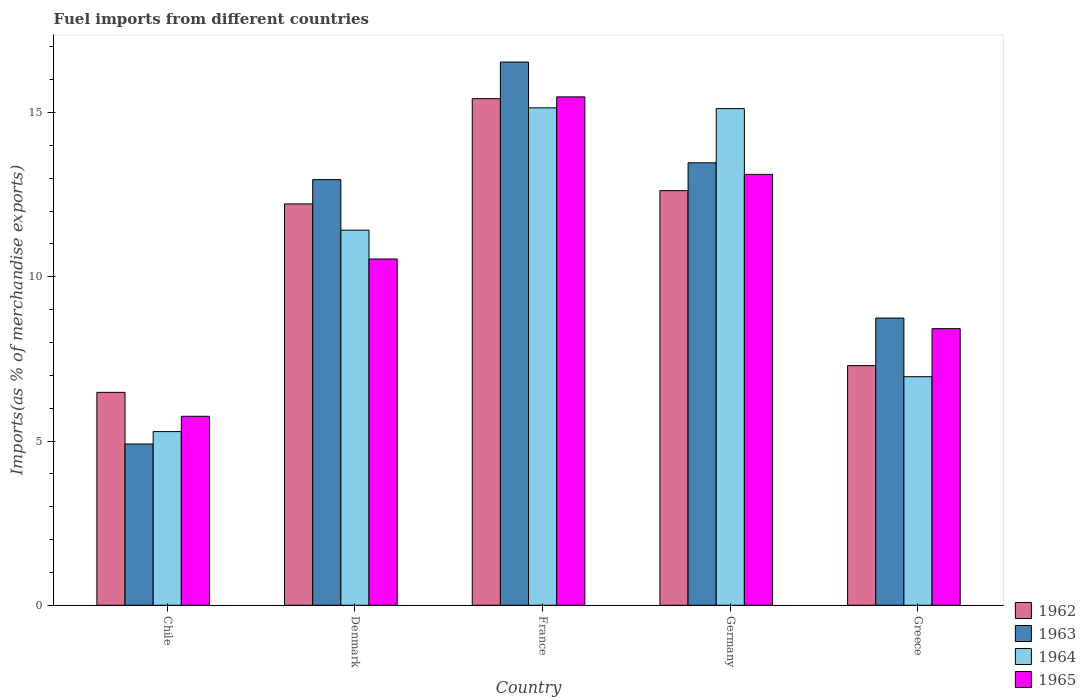How many different coloured bars are there?
Provide a short and direct response. 4. Are the number of bars per tick equal to the number of legend labels?
Your answer should be compact. Yes. Are the number of bars on each tick of the X-axis equal?
Offer a terse response. Yes. How many bars are there on the 1st tick from the left?
Give a very brief answer. 4. How many bars are there on the 5th tick from the right?
Your answer should be compact. 4. In how many cases, is the number of bars for a given country not equal to the number of legend labels?
Your response must be concise. 0. What is the percentage of imports to different countries in 1965 in France?
Provide a short and direct response. 15.48. Across all countries, what is the maximum percentage of imports to different countries in 1964?
Provide a succinct answer. 15.14. Across all countries, what is the minimum percentage of imports to different countries in 1963?
Offer a terse response. 4.91. In which country was the percentage of imports to different countries in 1965 maximum?
Your response must be concise. France. In which country was the percentage of imports to different countries in 1963 minimum?
Your answer should be compact. Chile. What is the total percentage of imports to different countries in 1964 in the graph?
Provide a short and direct response. 53.93. What is the difference between the percentage of imports to different countries in 1962 in Chile and that in Greece?
Your response must be concise. -0.81. What is the difference between the percentage of imports to different countries in 1964 in France and the percentage of imports to different countries in 1965 in Greece?
Your response must be concise. 6.72. What is the average percentage of imports to different countries in 1963 per country?
Offer a very short reply. 11.32. What is the difference between the percentage of imports to different countries of/in 1963 and percentage of imports to different countries of/in 1965 in Germany?
Provide a succinct answer. 0.35. In how many countries, is the percentage of imports to different countries in 1965 greater than 1 %?
Keep it short and to the point. 5. What is the ratio of the percentage of imports to different countries in 1964 in Denmark to that in Greece?
Provide a short and direct response. 1.64. Is the percentage of imports to different countries in 1965 in Denmark less than that in Greece?
Make the answer very short. No. Is the difference between the percentage of imports to different countries in 1963 in Chile and France greater than the difference between the percentage of imports to different countries in 1965 in Chile and France?
Provide a succinct answer. No. What is the difference between the highest and the second highest percentage of imports to different countries in 1965?
Your answer should be very brief. -2.58. What is the difference between the highest and the lowest percentage of imports to different countries in 1965?
Your answer should be compact. 9.72. In how many countries, is the percentage of imports to different countries in 1964 greater than the average percentage of imports to different countries in 1964 taken over all countries?
Your answer should be very brief. 3. Is the sum of the percentage of imports to different countries in 1963 in Chile and France greater than the maximum percentage of imports to different countries in 1965 across all countries?
Provide a short and direct response. Yes. Is it the case that in every country, the sum of the percentage of imports to different countries in 1963 and percentage of imports to different countries in 1964 is greater than the sum of percentage of imports to different countries in 1965 and percentage of imports to different countries in 1962?
Provide a short and direct response. No. What does the 2nd bar from the left in Denmark represents?
Keep it short and to the point. 1963. What does the 2nd bar from the right in Germany represents?
Make the answer very short. 1964. Is it the case that in every country, the sum of the percentage of imports to different countries in 1964 and percentage of imports to different countries in 1962 is greater than the percentage of imports to different countries in 1965?
Your answer should be very brief. Yes. How many bars are there?
Your response must be concise. 20. Are the values on the major ticks of Y-axis written in scientific E-notation?
Give a very brief answer. No. Does the graph contain grids?
Your response must be concise. No. How are the legend labels stacked?
Keep it short and to the point. Vertical. What is the title of the graph?
Make the answer very short. Fuel imports from different countries. What is the label or title of the Y-axis?
Offer a very short reply. Imports(as % of merchandise exports). What is the Imports(as % of merchandise exports) of 1962 in Chile?
Keep it short and to the point. 6.48. What is the Imports(as % of merchandise exports) of 1963 in Chile?
Provide a short and direct response. 4.91. What is the Imports(as % of merchandise exports) of 1964 in Chile?
Your response must be concise. 5.29. What is the Imports(as % of merchandise exports) of 1965 in Chile?
Give a very brief answer. 5.75. What is the Imports(as % of merchandise exports) of 1962 in Denmark?
Your answer should be compact. 12.22. What is the Imports(as % of merchandise exports) of 1963 in Denmark?
Your answer should be compact. 12.96. What is the Imports(as % of merchandise exports) in 1964 in Denmark?
Give a very brief answer. 11.42. What is the Imports(as % of merchandise exports) of 1965 in Denmark?
Your answer should be very brief. 10.54. What is the Imports(as % of merchandise exports) of 1962 in France?
Give a very brief answer. 15.42. What is the Imports(as % of merchandise exports) in 1963 in France?
Keep it short and to the point. 16.54. What is the Imports(as % of merchandise exports) in 1964 in France?
Your response must be concise. 15.14. What is the Imports(as % of merchandise exports) in 1965 in France?
Keep it short and to the point. 15.48. What is the Imports(as % of merchandise exports) in 1962 in Germany?
Offer a very short reply. 12.62. What is the Imports(as % of merchandise exports) of 1963 in Germany?
Ensure brevity in your answer.  13.47. What is the Imports(as % of merchandise exports) of 1964 in Germany?
Provide a short and direct response. 15.12. What is the Imports(as % of merchandise exports) of 1965 in Germany?
Your answer should be very brief. 13.12. What is the Imports(as % of merchandise exports) in 1962 in Greece?
Make the answer very short. 7.3. What is the Imports(as % of merchandise exports) in 1963 in Greece?
Your answer should be very brief. 8.74. What is the Imports(as % of merchandise exports) in 1964 in Greece?
Provide a succinct answer. 6.96. What is the Imports(as % of merchandise exports) of 1965 in Greece?
Make the answer very short. 8.42. Across all countries, what is the maximum Imports(as % of merchandise exports) in 1962?
Make the answer very short. 15.42. Across all countries, what is the maximum Imports(as % of merchandise exports) in 1963?
Offer a terse response. 16.54. Across all countries, what is the maximum Imports(as % of merchandise exports) of 1964?
Give a very brief answer. 15.14. Across all countries, what is the maximum Imports(as % of merchandise exports) in 1965?
Your answer should be compact. 15.48. Across all countries, what is the minimum Imports(as % of merchandise exports) of 1962?
Offer a terse response. 6.48. Across all countries, what is the minimum Imports(as % of merchandise exports) of 1963?
Your response must be concise. 4.91. Across all countries, what is the minimum Imports(as % of merchandise exports) in 1964?
Give a very brief answer. 5.29. Across all countries, what is the minimum Imports(as % of merchandise exports) of 1965?
Give a very brief answer. 5.75. What is the total Imports(as % of merchandise exports) of 1962 in the graph?
Your answer should be very brief. 54.04. What is the total Imports(as % of merchandise exports) of 1963 in the graph?
Provide a succinct answer. 56.62. What is the total Imports(as % of merchandise exports) of 1964 in the graph?
Give a very brief answer. 53.93. What is the total Imports(as % of merchandise exports) of 1965 in the graph?
Offer a terse response. 53.31. What is the difference between the Imports(as % of merchandise exports) in 1962 in Chile and that in Denmark?
Offer a terse response. -5.74. What is the difference between the Imports(as % of merchandise exports) of 1963 in Chile and that in Denmark?
Your answer should be very brief. -8.05. What is the difference between the Imports(as % of merchandise exports) in 1964 in Chile and that in Denmark?
Your answer should be very brief. -6.13. What is the difference between the Imports(as % of merchandise exports) of 1965 in Chile and that in Denmark?
Give a very brief answer. -4.79. What is the difference between the Imports(as % of merchandise exports) of 1962 in Chile and that in France?
Provide a succinct answer. -8.94. What is the difference between the Imports(as % of merchandise exports) in 1963 in Chile and that in France?
Ensure brevity in your answer.  -11.63. What is the difference between the Imports(as % of merchandise exports) of 1964 in Chile and that in France?
Your answer should be very brief. -9.86. What is the difference between the Imports(as % of merchandise exports) of 1965 in Chile and that in France?
Your answer should be very brief. -9.72. What is the difference between the Imports(as % of merchandise exports) in 1962 in Chile and that in Germany?
Provide a succinct answer. -6.14. What is the difference between the Imports(as % of merchandise exports) of 1963 in Chile and that in Germany?
Provide a short and direct response. -8.56. What is the difference between the Imports(as % of merchandise exports) of 1964 in Chile and that in Germany?
Keep it short and to the point. -9.83. What is the difference between the Imports(as % of merchandise exports) of 1965 in Chile and that in Germany?
Keep it short and to the point. -7.36. What is the difference between the Imports(as % of merchandise exports) of 1962 in Chile and that in Greece?
Ensure brevity in your answer.  -0.81. What is the difference between the Imports(as % of merchandise exports) of 1963 in Chile and that in Greece?
Offer a terse response. -3.83. What is the difference between the Imports(as % of merchandise exports) in 1964 in Chile and that in Greece?
Give a very brief answer. -1.67. What is the difference between the Imports(as % of merchandise exports) of 1965 in Chile and that in Greece?
Keep it short and to the point. -2.67. What is the difference between the Imports(as % of merchandise exports) of 1962 in Denmark and that in France?
Your response must be concise. -3.2. What is the difference between the Imports(as % of merchandise exports) of 1963 in Denmark and that in France?
Your answer should be very brief. -3.58. What is the difference between the Imports(as % of merchandise exports) in 1964 in Denmark and that in France?
Provide a succinct answer. -3.72. What is the difference between the Imports(as % of merchandise exports) of 1965 in Denmark and that in France?
Provide a succinct answer. -4.94. What is the difference between the Imports(as % of merchandise exports) in 1962 in Denmark and that in Germany?
Provide a succinct answer. -0.4. What is the difference between the Imports(as % of merchandise exports) in 1963 in Denmark and that in Germany?
Your response must be concise. -0.51. What is the difference between the Imports(as % of merchandise exports) of 1964 in Denmark and that in Germany?
Make the answer very short. -3.7. What is the difference between the Imports(as % of merchandise exports) in 1965 in Denmark and that in Germany?
Offer a terse response. -2.58. What is the difference between the Imports(as % of merchandise exports) in 1962 in Denmark and that in Greece?
Provide a short and direct response. 4.92. What is the difference between the Imports(as % of merchandise exports) in 1963 in Denmark and that in Greece?
Offer a terse response. 4.21. What is the difference between the Imports(as % of merchandise exports) in 1964 in Denmark and that in Greece?
Your response must be concise. 4.46. What is the difference between the Imports(as % of merchandise exports) in 1965 in Denmark and that in Greece?
Give a very brief answer. 2.12. What is the difference between the Imports(as % of merchandise exports) in 1962 in France and that in Germany?
Your response must be concise. 2.8. What is the difference between the Imports(as % of merchandise exports) of 1963 in France and that in Germany?
Give a very brief answer. 3.07. What is the difference between the Imports(as % of merchandise exports) in 1964 in France and that in Germany?
Give a very brief answer. 0.02. What is the difference between the Imports(as % of merchandise exports) in 1965 in France and that in Germany?
Offer a very short reply. 2.36. What is the difference between the Imports(as % of merchandise exports) of 1962 in France and that in Greece?
Keep it short and to the point. 8.13. What is the difference between the Imports(as % of merchandise exports) in 1963 in France and that in Greece?
Your answer should be compact. 7.79. What is the difference between the Imports(as % of merchandise exports) of 1964 in France and that in Greece?
Your response must be concise. 8.19. What is the difference between the Imports(as % of merchandise exports) in 1965 in France and that in Greece?
Give a very brief answer. 7.06. What is the difference between the Imports(as % of merchandise exports) in 1962 in Germany and that in Greece?
Offer a very short reply. 5.33. What is the difference between the Imports(as % of merchandise exports) in 1963 in Germany and that in Greece?
Give a very brief answer. 4.73. What is the difference between the Imports(as % of merchandise exports) of 1964 in Germany and that in Greece?
Keep it short and to the point. 8.16. What is the difference between the Imports(as % of merchandise exports) in 1965 in Germany and that in Greece?
Provide a short and direct response. 4.7. What is the difference between the Imports(as % of merchandise exports) of 1962 in Chile and the Imports(as % of merchandise exports) of 1963 in Denmark?
Offer a very short reply. -6.48. What is the difference between the Imports(as % of merchandise exports) in 1962 in Chile and the Imports(as % of merchandise exports) in 1964 in Denmark?
Your answer should be very brief. -4.94. What is the difference between the Imports(as % of merchandise exports) in 1962 in Chile and the Imports(as % of merchandise exports) in 1965 in Denmark?
Give a very brief answer. -4.06. What is the difference between the Imports(as % of merchandise exports) in 1963 in Chile and the Imports(as % of merchandise exports) in 1964 in Denmark?
Make the answer very short. -6.51. What is the difference between the Imports(as % of merchandise exports) in 1963 in Chile and the Imports(as % of merchandise exports) in 1965 in Denmark?
Your answer should be very brief. -5.63. What is the difference between the Imports(as % of merchandise exports) in 1964 in Chile and the Imports(as % of merchandise exports) in 1965 in Denmark?
Make the answer very short. -5.25. What is the difference between the Imports(as % of merchandise exports) in 1962 in Chile and the Imports(as % of merchandise exports) in 1963 in France?
Make the answer very short. -10.06. What is the difference between the Imports(as % of merchandise exports) of 1962 in Chile and the Imports(as % of merchandise exports) of 1964 in France?
Provide a short and direct response. -8.66. What is the difference between the Imports(as % of merchandise exports) in 1962 in Chile and the Imports(as % of merchandise exports) in 1965 in France?
Your answer should be compact. -9. What is the difference between the Imports(as % of merchandise exports) in 1963 in Chile and the Imports(as % of merchandise exports) in 1964 in France?
Offer a terse response. -10.23. What is the difference between the Imports(as % of merchandise exports) in 1963 in Chile and the Imports(as % of merchandise exports) in 1965 in France?
Offer a terse response. -10.57. What is the difference between the Imports(as % of merchandise exports) of 1964 in Chile and the Imports(as % of merchandise exports) of 1965 in France?
Give a very brief answer. -10.19. What is the difference between the Imports(as % of merchandise exports) of 1962 in Chile and the Imports(as % of merchandise exports) of 1963 in Germany?
Your answer should be very brief. -6.99. What is the difference between the Imports(as % of merchandise exports) of 1962 in Chile and the Imports(as % of merchandise exports) of 1964 in Germany?
Ensure brevity in your answer.  -8.64. What is the difference between the Imports(as % of merchandise exports) of 1962 in Chile and the Imports(as % of merchandise exports) of 1965 in Germany?
Offer a very short reply. -6.64. What is the difference between the Imports(as % of merchandise exports) of 1963 in Chile and the Imports(as % of merchandise exports) of 1964 in Germany?
Provide a succinct answer. -10.21. What is the difference between the Imports(as % of merchandise exports) in 1963 in Chile and the Imports(as % of merchandise exports) in 1965 in Germany?
Make the answer very short. -8.21. What is the difference between the Imports(as % of merchandise exports) in 1964 in Chile and the Imports(as % of merchandise exports) in 1965 in Germany?
Offer a terse response. -7.83. What is the difference between the Imports(as % of merchandise exports) in 1962 in Chile and the Imports(as % of merchandise exports) in 1963 in Greece?
Your answer should be very brief. -2.26. What is the difference between the Imports(as % of merchandise exports) of 1962 in Chile and the Imports(as % of merchandise exports) of 1964 in Greece?
Your answer should be very brief. -0.48. What is the difference between the Imports(as % of merchandise exports) of 1962 in Chile and the Imports(as % of merchandise exports) of 1965 in Greece?
Your response must be concise. -1.94. What is the difference between the Imports(as % of merchandise exports) in 1963 in Chile and the Imports(as % of merchandise exports) in 1964 in Greece?
Offer a terse response. -2.05. What is the difference between the Imports(as % of merchandise exports) in 1963 in Chile and the Imports(as % of merchandise exports) in 1965 in Greece?
Provide a succinct answer. -3.51. What is the difference between the Imports(as % of merchandise exports) in 1964 in Chile and the Imports(as % of merchandise exports) in 1965 in Greece?
Your answer should be compact. -3.13. What is the difference between the Imports(as % of merchandise exports) of 1962 in Denmark and the Imports(as % of merchandise exports) of 1963 in France?
Provide a short and direct response. -4.32. What is the difference between the Imports(as % of merchandise exports) of 1962 in Denmark and the Imports(as % of merchandise exports) of 1964 in France?
Give a very brief answer. -2.92. What is the difference between the Imports(as % of merchandise exports) in 1962 in Denmark and the Imports(as % of merchandise exports) in 1965 in France?
Ensure brevity in your answer.  -3.26. What is the difference between the Imports(as % of merchandise exports) of 1963 in Denmark and the Imports(as % of merchandise exports) of 1964 in France?
Your response must be concise. -2.19. What is the difference between the Imports(as % of merchandise exports) in 1963 in Denmark and the Imports(as % of merchandise exports) in 1965 in France?
Keep it short and to the point. -2.52. What is the difference between the Imports(as % of merchandise exports) in 1964 in Denmark and the Imports(as % of merchandise exports) in 1965 in France?
Your response must be concise. -4.06. What is the difference between the Imports(as % of merchandise exports) of 1962 in Denmark and the Imports(as % of merchandise exports) of 1963 in Germany?
Your response must be concise. -1.25. What is the difference between the Imports(as % of merchandise exports) in 1962 in Denmark and the Imports(as % of merchandise exports) in 1964 in Germany?
Offer a terse response. -2.9. What is the difference between the Imports(as % of merchandise exports) in 1962 in Denmark and the Imports(as % of merchandise exports) in 1965 in Germany?
Your response must be concise. -0.9. What is the difference between the Imports(as % of merchandise exports) of 1963 in Denmark and the Imports(as % of merchandise exports) of 1964 in Germany?
Give a very brief answer. -2.16. What is the difference between the Imports(as % of merchandise exports) of 1963 in Denmark and the Imports(as % of merchandise exports) of 1965 in Germany?
Your answer should be compact. -0.16. What is the difference between the Imports(as % of merchandise exports) in 1964 in Denmark and the Imports(as % of merchandise exports) in 1965 in Germany?
Your answer should be compact. -1.7. What is the difference between the Imports(as % of merchandise exports) in 1962 in Denmark and the Imports(as % of merchandise exports) in 1963 in Greece?
Your response must be concise. 3.48. What is the difference between the Imports(as % of merchandise exports) in 1962 in Denmark and the Imports(as % of merchandise exports) in 1964 in Greece?
Provide a succinct answer. 5.26. What is the difference between the Imports(as % of merchandise exports) of 1962 in Denmark and the Imports(as % of merchandise exports) of 1965 in Greece?
Your answer should be compact. 3.8. What is the difference between the Imports(as % of merchandise exports) of 1963 in Denmark and the Imports(as % of merchandise exports) of 1964 in Greece?
Your response must be concise. 6. What is the difference between the Imports(as % of merchandise exports) of 1963 in Denmark and the Imports(as % of merchandise exports) of 1965 in Greece?
Offer a terse response. 4.54. What is the difference between the Imports(as % of merchandise exports) of 1964 in Denmark and the Imports(as % of merchandise exports) of 1965 in Greece?
Offer a very short reply. 3. What is the difference between the Imports(as % of merchandise exports) in 1962 in France and the Imports(as % of merchandise exports) in 1963 in Germany?
Keep it short and to the point. 1.95. What is the difference between the Imports(as % of merchandise exports) in 1962 in France and the Imports(as % of merchandise exports) in 1964 in Germany?
Make the answer very short. 0.3. What is the difference between the Imports(as % of merchandise exports) in 1962 in France and the Imports(as % of merchandise exports) in 1965 in Germany?
Your answer should be very brief. 2.31. What is the difference between the Imports(as % of merchandise exports) of 1963 in France and the Imports(as % of merchandise exports) of 1964 in Germany?
Provide a short and direct response. 1.42. What is the difference between the Imports(as % of merchandise exports) of 1963 in France and the Imports(as % of merchandise exports) of 1965 in Germany?
Your answer should be very brief. 3.42. What is the difference between the Imports(as % of merchandise exports) in 1964 in France and the Imports(as % of merchandise exports) in 1965 in Germany?
Give a very brief answer. 2.03. What is the difference between the Imports(as % of merchandise exports) in 1962 in France and the Imports(as % of merchandise exports) in 1963 in Greece?
Offer a terse response. 6.68. What is the difference between the Imports(as % of merchandise exports) of 1962 in France and the Imports(as % of merchandise exports) of 1964 in Greece?
Offer a terse response. 8.46. What is the difference between the Imports(as % of merchandise exports) of 1962 in France and the Imports(as % of merchandise exports) of 1965 in Greece?
Keep it short and to the point. 7. What is the difference between the Imports(as % of merchandise exports) of 1963 in France and the Imports(as % of merchandise exports) of 1964 in Greece?
Provide a succinct answer. 9.58. What is the difference between the Imports(as % of merchandise exports) in 1963 in France and the Imports(as % of merchandise exports) in 1965 in Greece?
Offer a very short reply. 8.12. What is the difference between the Imports(as % of merchandise exports) in 1964 in France and the Imports(as % of merchandise exports) in 1965 in Greece?
Provide a short and direct response. 6.72. What is the difference between the Imports(as % of merchandise exports) in 1962 in Germany and the Imports(as % of merchandise exports) in 1963 in Greece?
Make the answer very short. 3.88. What is the difference between the Imports(as % of merchandise exports) of 1962 in Germany and the Imports(as % of merchandise exports) of 1964 in Greece?
Keep it short and to the point. 5.66. What is the difference between the Imports(as % of merchandise exports) in 1962 in Germany and the Imports(as % of merchandise exports) in 1965 in Greece?
Provide a short and direct response. 4.2. What is the difference between the Imports(as % of merchandise exports) of 1963 in Germany and the Imports(as % of merchandise exports) of 1964 in Greece?
Your answer should be very brief. 6.51. What is the difference between the Imports(as % of merchandise exports) in 1963 in Germany and the Imports(as % of merchandise exports) in 1965 in Greece?
Provide a succinct answer. 5.05. What is the difference between the Imports(as % of merchandise exports) in 1964 in Germany and the Imports(as % of merchandise exports) in 1965 in Greece?
Make the answer very short. 6.7. What is the average Imports(as % of merchandise exports) of 1962 per country?
Keep it short and to the point. 10.81. What is the average Imports(as % of merchandise exports) of 1963 per country?
Your response must be concise. 11.32. What is the average Imports(as % of merchandise exports) of 1964 per country?
Provide a succinct answer. 10.79. What is the average Imports(as % of merchandise exports) of 1965 per country?
Your answer should be very brief. 10.66. What is the difference between the Imports(as % of merchandise exports) in 1962 and Imports(as % of merchandise exports) in 1963 in Chile?
Provide a succinct answer. 1.57. What is the difference between the Imports(as % of merchandise exports) of 1962 and Imports(as % of merchandise exports) of 1964 in Chile?
Ensure brevity in your answer.  1.19. What is the difference between the Imports(as % of merchandise exports) of 1962 and Imports(as % of merchandise exports) of 1965 in Chile?
Keep it short and to the point. 0.73. What is the difference between the Imports(as % of merchandise exports) of 1963 and Imports(as % of merchandise exports) of 1964 in Chile?
Keep it short and to the point. -0.38. What is the difference between the Imports(as % of merchandise exports) of 1963 and Imports(as % of merchandise exports) of 1965 in Chile?
Offer a terse response. -0.84. What is the difference between the Imports(as % of merchandise exports) of 1964 and Imports(as % of merchandise exports) of 1965 in Chile?
Offer a terse response. -0.47. What is the difference between the Imports(as % of merchandise exports) in 1962 and Imports(as % of merchandise exports) in 1963 in Denmark?
Ensure brevity in your answer.  -0.74. What is the difference between the Imports(as % of merchandise exports) of 1962 and Imports(as % of merchandise exports) of 1964 in Denmark?
Ensure brevity in your answer.  0.8. What is the difference between the Imports(as % of merchandise exports) of 1962 and Imports(as % of merchandise exports) of 1965 in Denmark?
Give a very brief answer. 1.68. What is the difference between the Imports(as % of merchandise exports) in 1963 and Imports(as % of merchandise exports) in 1964 in Denmark?
Offer a very short reply. 1.54. What is the difference between the Imports(as % of merchandise exports) of 1963 and Imports(as % of merchandise exports) of 1965 in Denmark?
Offer a terse response. 2.42. What is the difference between the Imports(as % of merchandise exports) of 1964 and Imports(as % of merchandise exports) of 1965 in Denmark?
Keep it short and to the point. 0.88. What is the difference between the Imports(as % of merchandise exports) of 1962 and Imports(as % of merchandise exports) of 1963 in France?
Make the answer very short. -1.12. What is the difference between the Imports(as % of merchandise exports) of 1962 and Imports(as % of merchandise exports) of 1964 in France?
Make the answer very short. 0.28. What is the difference between the Imports(as % of merchandise exports) in 1962 and Imports(as % of merchandise exports) in 1965 in France?
Offer a terse response. -0.05. What is the difference between the Imports(as % of merchandise exports) of 1963 and Imports(as % of merchandise exports) of 1964 in France?
Your answer should be very brief. 1.39. What is the difference between the Imports(as % of merchandise exports) in 1963 and Imports(as % of merchandise exports) in 1965 in France?
Provide a short and direct response. 1.06. What is the difference between the Imports(as % of merchandise exports) of 1964 and Imports(as % of merchandise exports) of 1965 in France?
Give a very brief answer. -0.33. What is the difference between the Imports(as % of merchandise exports) in 1962 and Imports(as % of merchandise exports) in 1963 in Germany?
Offer a terse response. -0.85. What is the difference between the Imports(as % of merchandise exports) of 1962 and Imports(as % of merchandise exports) of 1964 in Germany?
Your response must be concise. -2.5. What is the difference between the Imports(as % of merchandise exports) of 1962 and Imports(as % of merchandise exports) of 1965 in Germany?
Your response must be concise. -0.49. What is the difference between the Imports(as % of merchandise exports) of 1963 and Imports(as % of merchandise exports) of 1964 in Germany?
Your answer should be compact. -1.65. What is the difference between the Imports(as % of merchandise exports) of 1963 and Imports(as % of merchandise exports) of 1965 in Germany?
Offer a very short reply. 0.35. What is the difference between the Imports(as % of merchandise exports) of 1964 and Imports(as % of merchandise exports) of 1965 in Germany?
Offer a very short reply. 2. What is the difference between the Imports(as % of merchandise exports) of 1962 and Imports(as % of merchandise exports) of 1963 in Greece?
Your answer should be compact. -1.45. What is the difference between the Imports(as % of merchandise exports) in 1962 and Imports(as % of merchandise exports) in 1964 in Greece?
Your answer should be very brief. 0.34. What is the difference between the Imports(as % of merchandise exports) in 1962 and Imports(as % of merchandise exports) in 1965 in Greece?
Keep it short and to the point. -1.13. What is the difference between the Imports(as % of merchandise exports) of 1963 and Imports(as % of merchandise exports) of 1964 in Greece?
Your answer should be very brief. 1.79. What is the difference between the Imports(as % of merchandise exports) in 1963 and Imports(as % of merchandise exports) in 1965 in Greece?
Offer a terse response. 0.32. What is the difference between the Imports(as % of merchandise exports) in 1964 and Imports(as % of merchandise exports) in 1965 in Greece?
Make the answer very short. -1.46. What is the ratio of the Imports(as % of merchandise exports) of 1962 in Chile to that in Denmark?
Keep it short and to the point. 0.53. What is the ratio of the Imports(as % of merchandise exports) in 1963 in Chile to that in Denmark?
Offer a very short reply. 0.38. What is the ratio of the Imports(as % of merchandise exports) of 1964 in Chile to that in Denmark?
Provide a short and direct response. 0.46. What is the ratio of the Imports(as % of merchandise exports) in 1965 in Chile to that in Denmark?
Offer a terse response. 0.55. What is the ratio of the Imports(as % of merchandise exports) of 1962 in Chile to that in France?
Give a very brief answer. 0.42. What is the ratio of the Imports(as % of merchandise exports) of 1963 in Chile to that in France?
Ensure brevity in your answer.  0.3. What is the ratio of the Imports(as % of merchandise exports) of 1964 in Chile to that in France?
Provide a succinct answer. 0.35. What is the ratio of the Imports(as % of merchandise exports) in 1965 in Chile to that in France?
Your answer should be very brief. 0.37. What is the ratio of the Imports(as % of merchandise exports) in 1962 in Chile to that in Germany?
Make the answer very short. 0.51. What is the ratio of the Imports(as % of merchandise exports) of 1963 in Chile to that in Germany?
Make the answer very short. 0.36. What is the ratio of the Imports(as % of merchandise exports) in 1964 in Chile to that in Germany?
Your answer should be compact. 0.35. What is the ratio of the Imports(as % of merchandise exports) in 1965 in Chile to that in Germany?
Your response must be concise. 0.44. What is the ratio of the Imports(as % of merchandise exports) of 1962 in Chile to that in Greece?
Offer a very short reply. 0.89. What is the ratio of the Imports(as % of merchandise exports) of 1963 in Chile to that in Greece?
Offer a very short reply. 0.56. What is the ratio of the Imports(as % of merchandise exports) in 1964 in Chile to that in Greece?
Offer a terse response. 0.76. What is the ratio of the Imports(as % of merchandise exports) in 1965 in Chile to that in Greece?
Your response must be concise. 0.68. What is the ratio of the Imports(as % of merchandise exports) in 1962 in Denmark to that in France?
Offer a very short reply. 0.79. What is the ratio of the Imports(as % of merchandise exports) in 1963 in Denmark to that in France?
Make the answer very short. 0.78. What is the ratio of the Imports(as % of merchandise exports) in 1964 in Denmark to that in France?
Make the answer very short. 0.75. What is the ratio of the Imports(as % of merchandise exports) in 1965 in Denmark to that in France?
Offer a very short reply. 0.68. What is the ratio of the Imports(as % of merchandise exports) of 1962 in Denmark to that in Germany?
Your response must be concise. 0.97. What is the ratio of the Imports(as % of merchandise exports) of 1963 in Denmark to that in Germany?
Your response must be concise. 0.96. What is the ratio of the Imports(as % of merchandise exports) of 1964 in Denmark to that in Germany?
Make the answer very short. 0.76. What is the ratio of the Imports(as % of merchandise exports) of 1965 in Denmark to that in Germany?
Make the answer very short. 0.8. What is the ratio of the Imports(as % of merchandise exports) in 1962 in Denmark to that in Greece?
Your response must be concise. 1.67. What is the ratio of the Imports(as % of merchandise exports) of 1963 in Denmark to that in Greece?
Keep it short and to the point. 1.48. What is the ratio of the Imports(as % of merchandise exports) of 1964 in Denmark to that in Greece?
Provide a short and direct response. 1.64. What is the ratio of the Imports(as % of merchandise exports) of 1965 in Denmark to that in Greece?
Your answer should be compact. 1.25. What is the ratio of the Imports(as % of merchandise exports) in 1962 in France to that in Germany?
Offer a very short reply. 1.22. What is the ratio of the Imports(as % of merchandise exports) in 1963 in France to that in Germany?
Your answer should be very brief. 1.23. What is the ratio of the Imports(as % of merchandise exports) in 1965 in France to that in Germany?
Ensure brevity in your answer.  1.18. What is the ratio of the Imports(as % of merchandise exports) in 1962 in France to that in Greece?
Your answer should be very brief. 2.11. What is the ratio of the Imports(as % of merchandise exports) of 1963 in France to that in Greece?
Give a very brief answer. 1.89. What is the ratio of the Imports(as % of merchandise exports) in 1964 in France to that in Greece?
Your answer should be compact. 2.18. What is the ratio of the Imports(as % of merchandise exports) in 1965 in France to that in Greece?
Make the answer very short. 1.84. What is the ratio of the Imports(as % of merchandise exports) of 1962 in Germany to that in Greece?
Keep it short and to the point. 1.73. What is the ratio of the Imports(as % of merchandise exports) of 1963 in Germany to that in Greece?
Your answer should be compact. 1.54. What is the ratio of the Imports(as % of merchandise exports) in 1964 in Germany to that in Greece?
Keep it short and to the point. 2.17. What is the ratio of the Imports(as % of merchandise exports) of 1965 in Germany to that in Greece?
Your answer should be very brief. 1.56. What is the difference between the highest and the second highest Imports(as % of merchandise exports) of 1962?
Your answer should be very brief. 2.8. What is the difference between the highest and the second highest Imports(as % of merchandise exports) in 1963?
Provide a succinct answer. 3.07. What is the difference between the highest and the second highest Imports(as % of merchandise exports) in 1964?
Offer a terse response. 0.02. What is the difference between the highest and the second highest Imports(as % of merchandise exports) in 1965?
Provide a short and direct response. 2.36. What is the difference between the highest and the lowest Imports(as % of merchandise exports) of 1962?
Give a very brief answer. 8.94. What is the difference between the highest and the lowest Imports(as % of merchandise exports) of 1963?
Your answer should be very brief. 11.63. What is the difference between the highest and the lowest Imports(as % of merchandise exports) of 1964?
Give a very brief answer. 9.86. What is the difference between the highest and the lowest Imports(as % of merchandise exports) of 1965?
Keep it short and to the point. 9.72. 